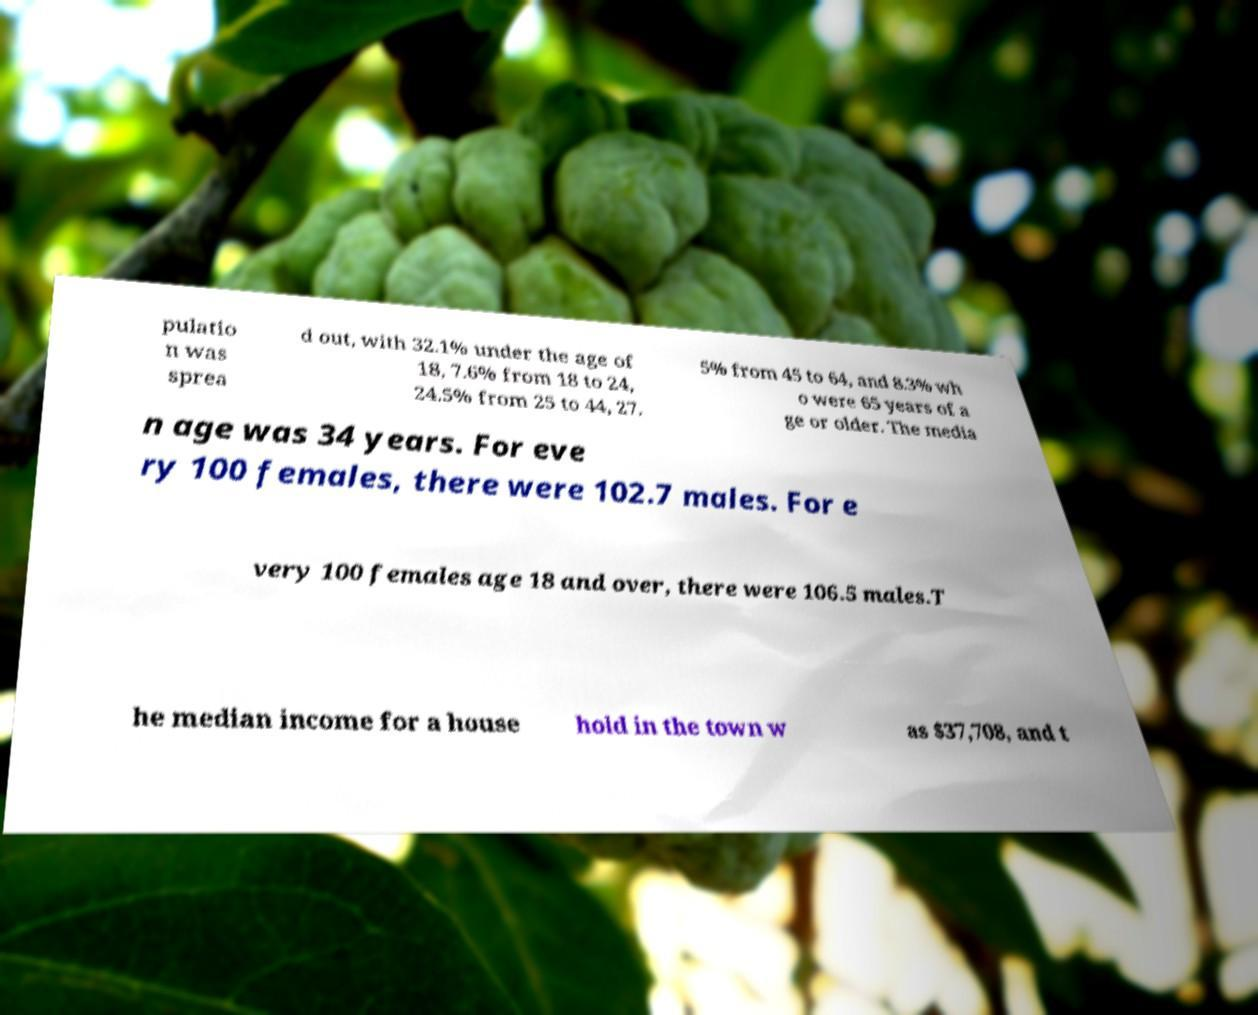Could you extract and type out the text from this image? pulatio n was sprea d out, with 32.1% under the age of 18, 7.6% from 18 to 24, 24.5% from 25 to 44, 27. 5% from 45 to 64, and 8.3% wh o were 65 years of a ge or older. The media n age was 34 years. For eve ry 100 females, there were 102.7 males. For e very 100 females age 18 and over, there were 106.5 males.T he median income for a house hold in the town w as $37,708, and t 